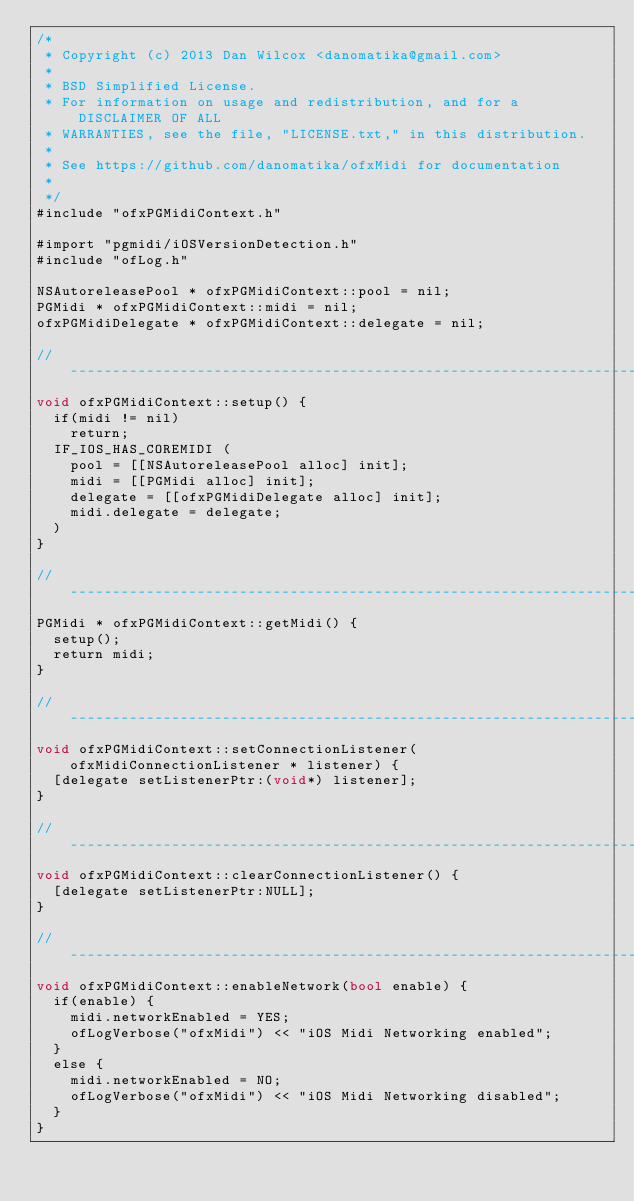Convert code to text. <code><loc_0><loc_0><loc_500><loc_500><_ObjectiveC_>/*
 * Copyright (c) 2013 Dan Wilcox <danomatika@gmail.com>
 *
 * BSD Simplified License.
 * For information on usage and redistribution, and for a DISCLAIMER OF ALL
 * WARRANTIES, see the file, "LICENSE.txt," in this distribution.
 *
 * See https://github.com/danomatika/ofxMidi for documentation
 *
 */
#include "ofxPGMidiContext.h"

#import "pgmidi/iOSVersionDetection.h"
#include "ofLog.h"

NSAutoreleasePool * ofxPGMidiContext::pool = nil;
PGMidi * ofxPGMidiContext::midi = nil;
ofxPGMidiDelegate * ofxPGMidiContext::delegate = nil;

// -----------------------------------------------------------------------------
void ofxPGMidiContext::setup() {
	if(midi != nil)
		return;
	IF_IOS_HAS_COREMIDI (
		pool = [[NSAutoreleasePool alloc] init];
		midi = [[PGMidi alloc] init];
		delegate = [[ofxPGMidiDelegate alloc] init];
		midi.delegate = delegate;
	)
}

// -----------------------------------------------------------------------------
PGMidi * ofxPGMidiContext::getMidi() {
	setup();
	return midi;
}

// -----------------------------------------------------------------------------
void ofxPGMidiContext::setConnectionListener(ofxMidiConnectionListener * listener) {
	[delegate setListenerPtr:(void*) listener];
}

// -----------------------------------------------------------------------------
void ofxPGMidiContext::clearConnectionListener() {
	[delegate setListenerPtr:NULL];
}

// -----------------------------------------------------------------------------
void ofxPGMidiContext::enableNetwork(bool enable) {
	if(enable) {
		midi.networkEnabled = YES;
		ofLogVerbose("ofxMidi") << "iOS Midi Networking enabled";
	}
	else {
		midi.networkEnabled = NO;
		ofLogVerbose("ofxMidi") << "iOS Midi Networking disabled";
	}
}
</code> 